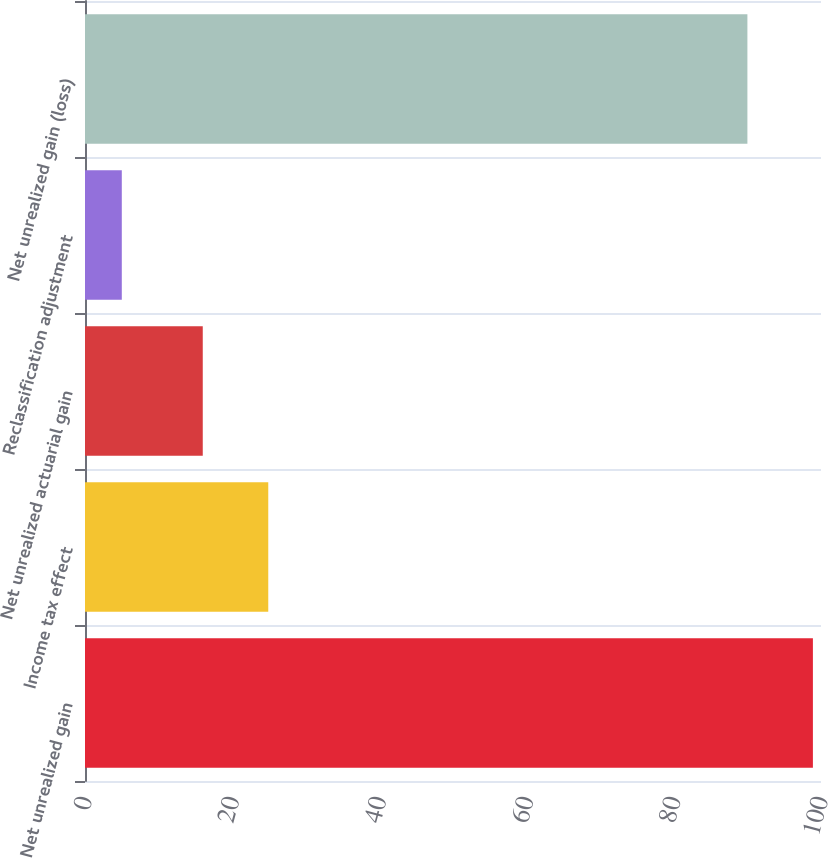Convert chart to OTSL. <chart><loc_0><loc_0><loc_500><loc_500><bar_chart><fcel>Net unrealized gain<fcel>Income tax effect<fcel>Net unrealized actuarial gain<fcel>Reclassification adjustment<fcel>Net unrealized gain (loss)<nl><fcel>98.9<fcel>24.9<fcel>16<fcel>5<fcel>90<nl></chart> 